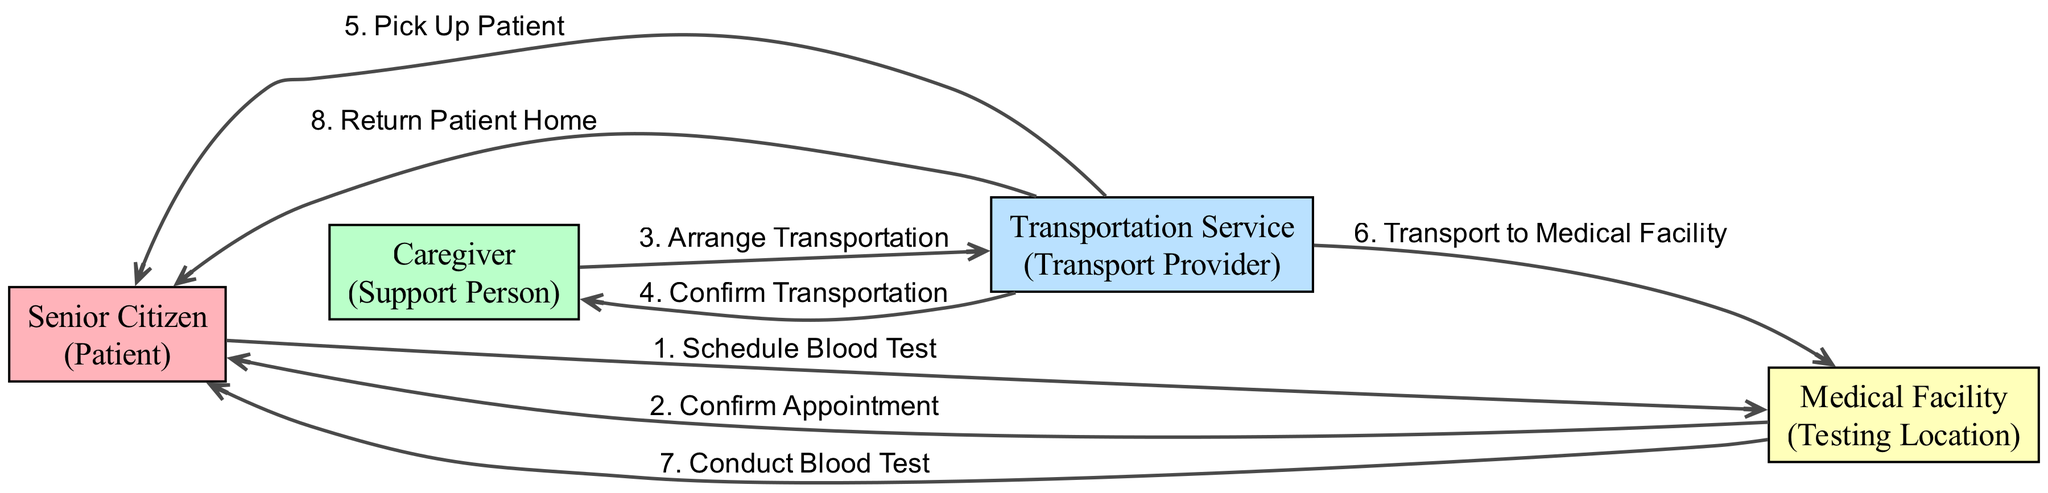What is the first action in the sequence? The sequence starts with the action "Schedule Blood Test" initiated by the Senior Citizen to the Medical Facility. This is the first step listed in the diagram.
Answer: Schedule Blood Test How many participants are involved in the process? The diagram lists four participants: Senior Citizen, Caregiver, Transportation Service, and Medical Facility. Each of these plays a distinct role in the transportation and testing process.
Answer: 4 Who confirms the appointment after it is scheduled? The Medical Facility confirms the appointment to the Senior Citizen after the blood test is scheduled. This is indicated as a directed action from Medical Facility to Senior Citizen in the sequence.
Answer: Medical Facility What is the last action in the diagram? The last action in the sequence is "Return Patient Home," which is performed by the Transportation Service for the Senior Citizen after the blood test is conducted.
Answer: Return Patient Home Which participant arranges transportation for the medical appointment? The Caregiver is responsible for arranging transportation. This is shown as an action flowing from Caregiver to Transportation Service in the diagram.
Answer: Caregiver How many actions are there in total in the sequence? There are eight distinct actions that form the complete sequence, as listed from scheduling the blood test to returning the patient home.
Answer: 8 What is the relationship between the Medical Facility and the Senior Citizen during the blood test? The Medical Facility conducts the blood test on the Senior Citizen, indicating a direct service relationship where the facility provides medical services to the patient.
Answer: Conduct Blood Test What action follows "Confirm Transportation" in the sequence? The action that follows "Confirm Transportation" is "Pick Up Patient," which shows that after transportation is confirmed, the service proceeds to pick up the Senior Citizen.
Answer: Pick Up Patient 